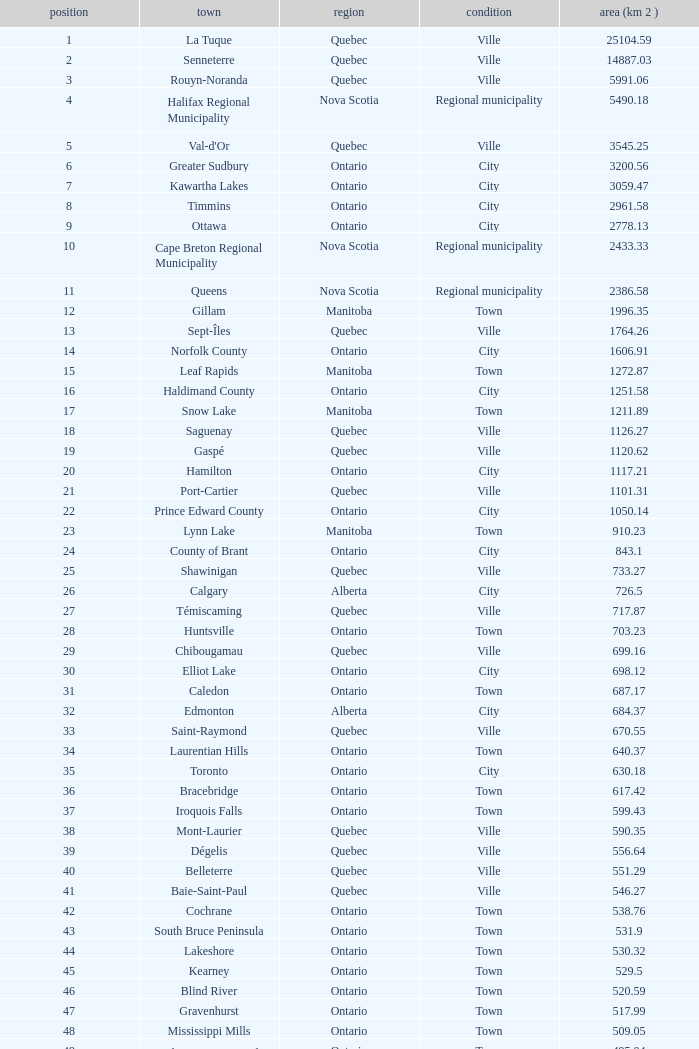What Municipality has a Rank of 44? Lakeshore. 